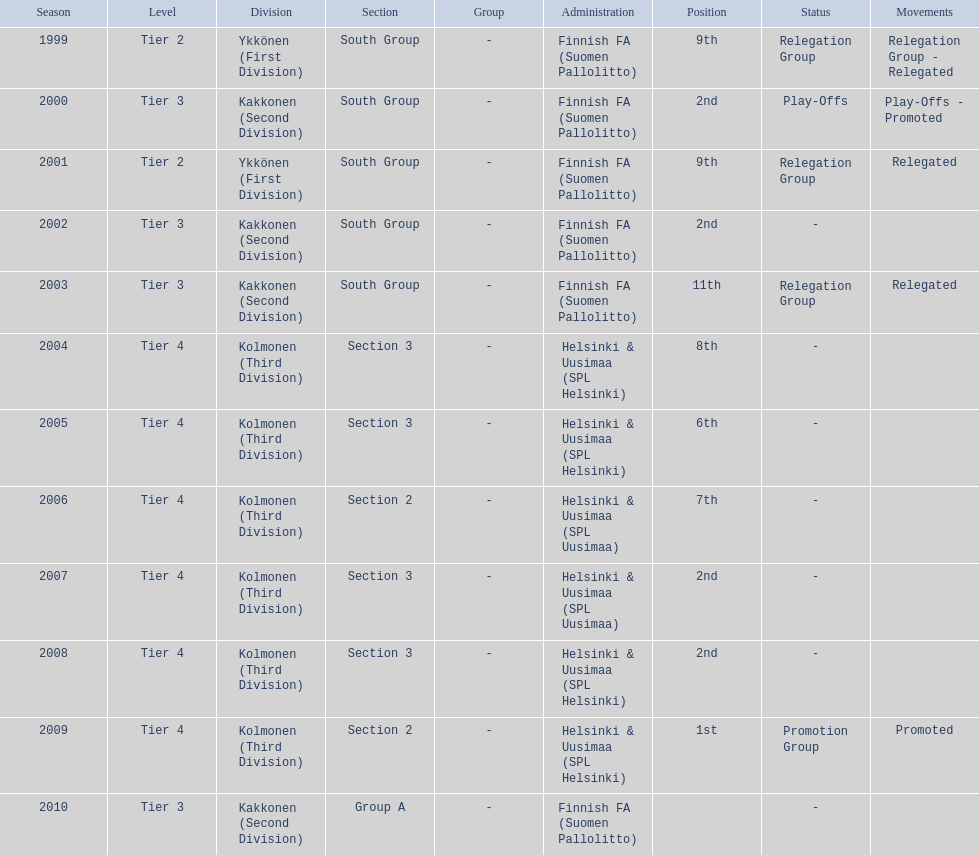How many times has this team been relegated? 3. 